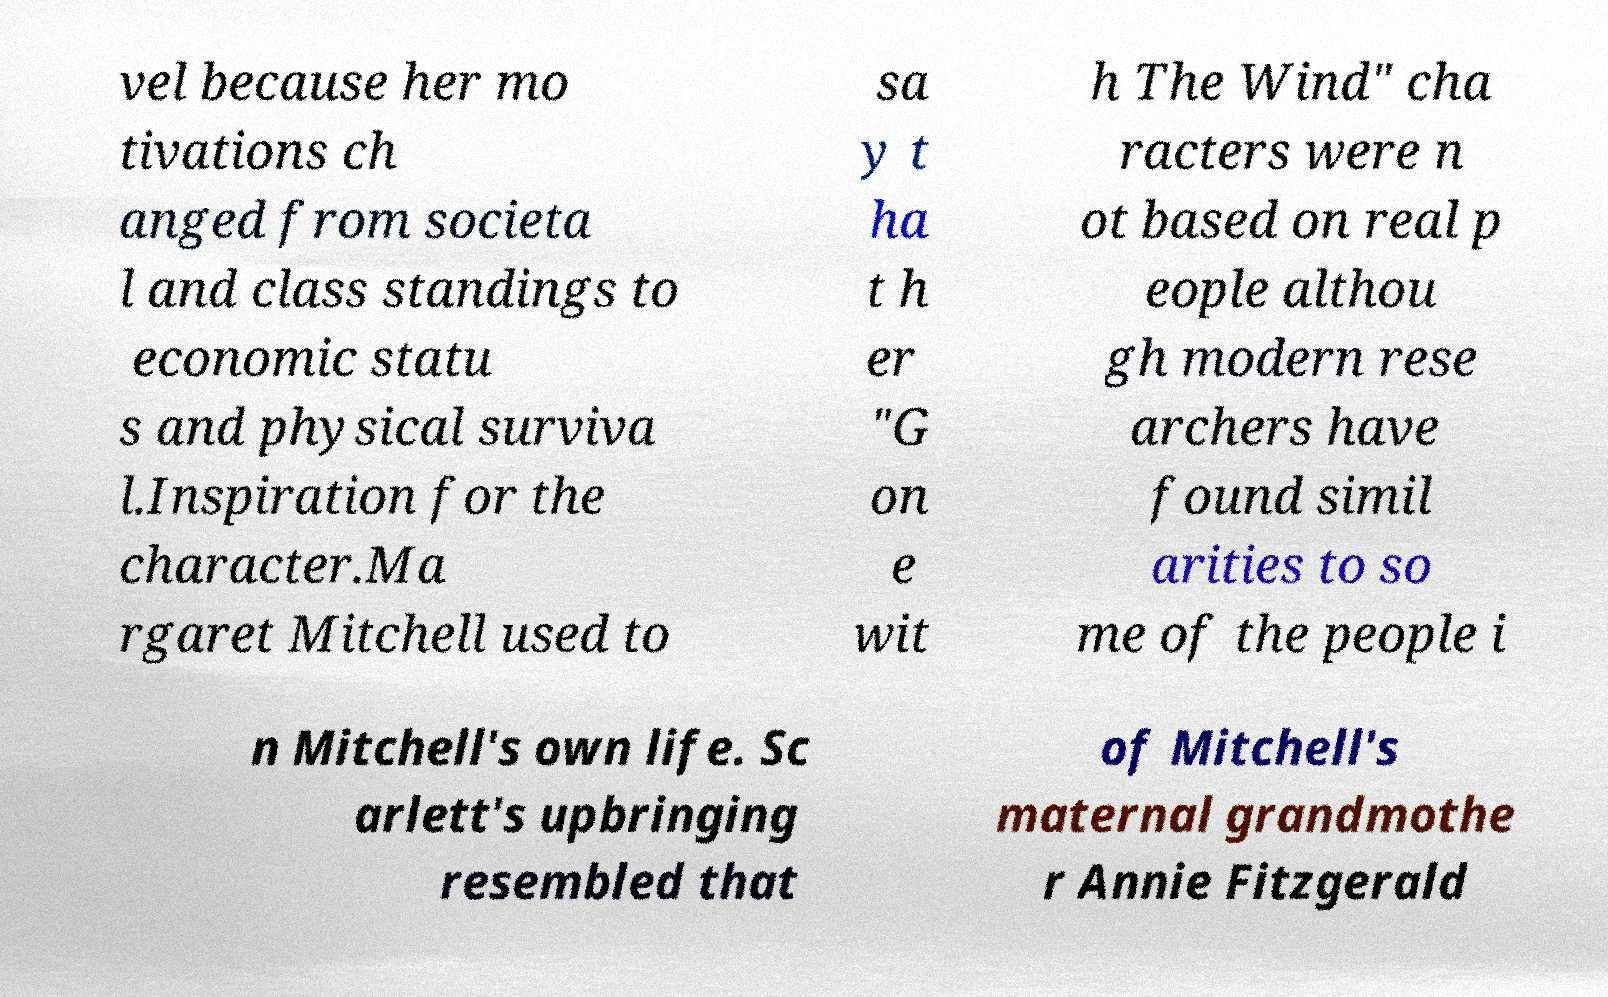Can you accurately transcribe the text from the provided image for me? vel because her mo tivations ch anged from societa l and class standings to economic statu s and physical surviva l.Inspiration for the character.Ma rgaret Mitchell used to sa y t ha t h er "G on e wit h The Wind" cha racters were n ot based on real p eople althou gh modern rese archers have found simil arities to so me of the people i n Mitchell's own life. Sc arlett's upbringing resembled that of Mitchell's maternal grandmothe r Annie Fitzgerald 